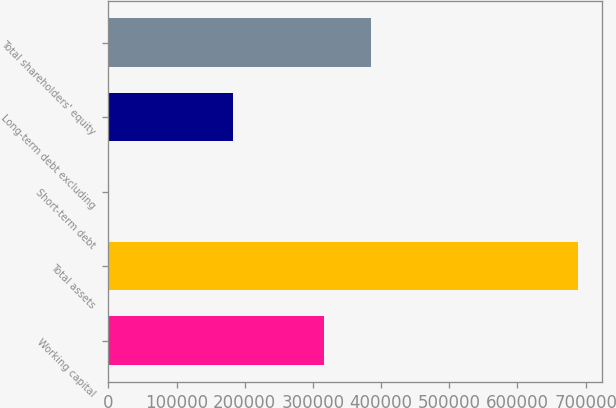<chart> <loc_0><loc_0><loc_500><loc_500><bar_chart><fcel>Working capital<fcel>Total assets<fcel>Short-term debt<fcel>Long-term debt excluding<fcel>Total shareholders' equity<nl><fcel>316335<fcel>689423<fcel>56<fcel>182678<fcel>385272<nl></chart> 